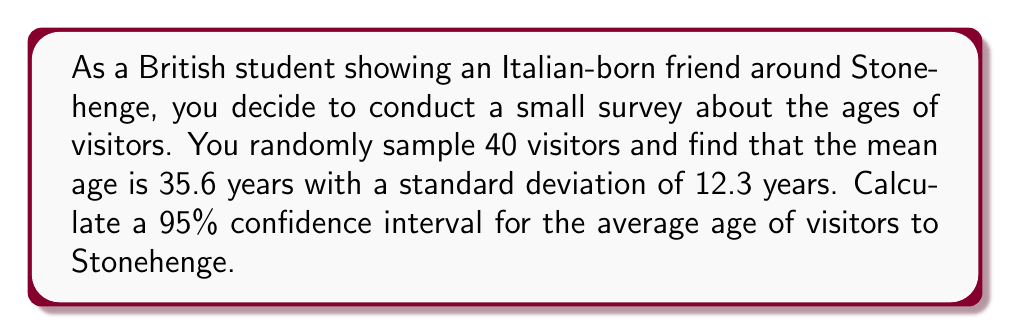Can you answer this question? To calculate the confidence interval, we'll follow these steps:

1) We're given:
   - Sample size: $n = 40$
   - Sample mean: $\bar{x} = 35.6$ years
   - Sample standard deviation: $s = 12.3$ years
   - Confidence level: 95%

2) For a 95% confidence interval, we use a z-score of 1.96 (assuming normal distribution).

3) The formula for the confidence interval is:

   $$\bar{x} \pm z \cdot \frac{s}{\sqrt{n}}$$

4) Calculate the standard error:
   $$SE = \frac{s}{\sqrt{n}} = \frac{12.3}{\sqrt{40}} = 1.945$$

5) Calculate the margin of error:
   $$ME = z \cdot SE = 1.96 \cdot 1.945 = 3.8122$$

6) Calculate the confidence interval:
   Lower bound: $35.6 - 3.8122 = 31.7878$
   Upper bound: $35.6 + 3.8122 = 39.4122$

7) Round to one decimal place for practical interpretation.
Answer: (31.8, 39.4) years 